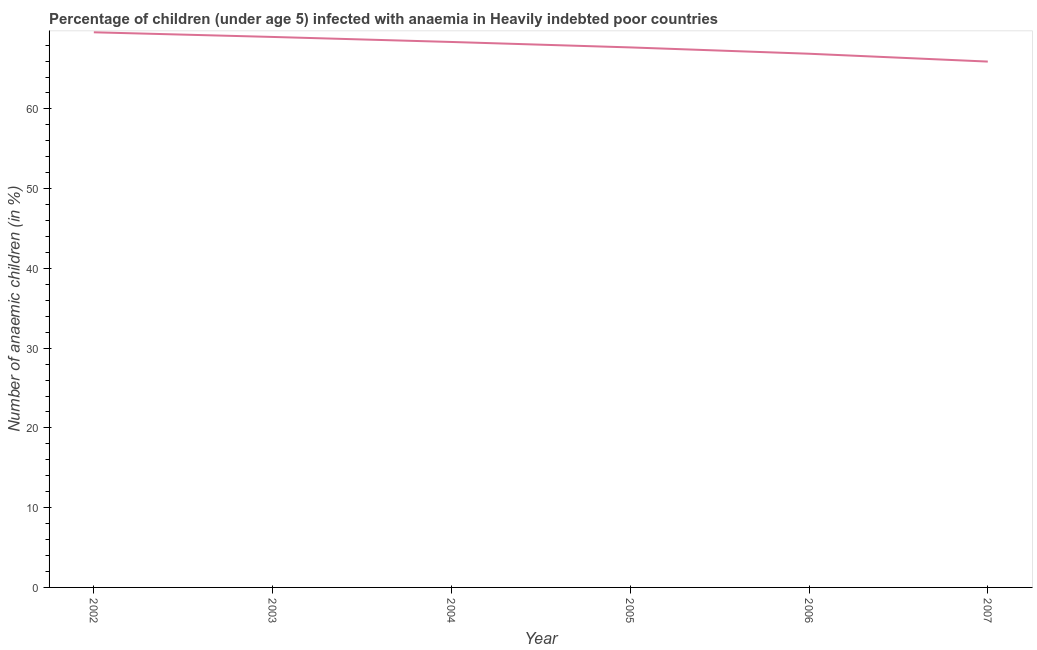What is the number of anaemic children in 2006?
Keep it short and to the point. 66.92. Across all years, what is the maximum number of anaemic children?
Keep it short and to the point. 69.61. Across all years, what is the minimum number of anaemic children?
Make the answer very short. 65.93. What is the sum of the number of anaemic children?
Offer a terse response. 407.59. What is the difference between the number of anaemic children in 2003 and 2004?
Offer a very short reply. 0.63. What is the average number of anaemic children per year?
Give a very brief answer. 67.93. What is the median number of anaemic children?
Provide a short and direct response. 68.05. Do a majority of the years between 2006 and 2004 (inclusive) have number of anaemic children greater than 44 %?
Your answer should be very brief. No. What is the ratio of the number of anaemic children in 2003 to that in 2005?
Provide a short and direct response. 1.02. What is the difference between the highest and the second highest number of anaemic children?
Offer a very short reply. 0.58. Is the sum of the number of anaemic children in 2003 and 2006 greater than the maximum number of anaemic children across all years?
Keep it short and to the point. Yes. What is the difference between the highest and the lowest number of anaemic children?
Your response must be concise. 3.67. Does the number of anaemic children monotonically increase over the years?
Keep it short and to the point. No. Are the values on the major ticks of Y-axis written in scientific E-notation?
Offer a very short reply. No. What is the title of the graph?
Provide a short and direct response. Percentage of children (under age 5) infected with anaemia in Heavily indebted poor countries. What is the label or title of the X-axis?
Give a very brief answer. Year. What is the label or title of the Y-axis?
Keep it short and to the point. Number of anaemic children (in %). What is the Number of anaemic children (in %) in 2002?
Keep it short and to the point. 69.61. What is the Number of anaemic children (in %) in 2003?
Offer a very short reply. 69.02. What is the Number of anaemic children (in %) of 2004?
Your answer should be compact. 68.39. What is the Number of anaemic children (in %) of 2005?
Ensure brevity in your answer.  67.71. What is the Number of anaemic children (in %) in 2006?
Ensure brevity in your answer.  66.92. What is the Number of anaemic children (in %) of 2007?
Keep it short and to the point. 65.93. What is the difference between the Number of anaemic children (in %) in 2002 and 2003?
Provide a short and direct response. 0.58. What is the difference between the Number of anaemic children (in %) in 2002 and 2004?
Keep it short and to the point. 1.21. What is the difference between the Number of anaemic children (in %) in 2002 and 2005?
Provide a succinct answer. 1.9. What is the difference between the Number of anaemic children (in %) in 2002 and 2006?
Your response must be concise. 2.69. What is the difference between the Number of anaemic children (in %) in 2002 and 2007?
Provide a short and direct response. 3.67. What is the difference between the Number of anaemic children (in %) in 2003 and 2004?
Offer a very short reply. 0.63. What is the difference between the Number of anaemic children (in %) in 2003 and 2005?
Offer a terse response. 1.31. What is the difference between the Number of anaemic children (in %) in 2003 and 2006?
Ensure brevity in your answer.  2.11. What is the difference between the Number of anaemic children (in %) in 2003 and 2007?
Your answer should be very brief. 3.09. What is the difference between the Number of anaemic children (in %) in 2004 and 2005?
Make the answer very short. 0.68. What is the difference between the Number of anaemic children (in %) in 2004 and 2006?
Your response must be concise. 1.48. What is the difference between the Number of anaemic children (in %) in 2004 and 2007?
Make the answer very short. 2.46. What is the difference between the Number of anaemic children (in %) in 2005 and 2006?
Provide a short and direct response. 0.79. What is the difference between the Number of anaemic children (in %) in 2005 and 2007?
Give a very brief answer. 1.78. What is the difference between the Number of anaemic children (in %) in 2006 and 2007?
Provide a short and direct response. 0.98. What is the ratio of the Number of anaemic children (in %) in 2002 to that in 2003?
Provide a short and direct response. 1.01. What is the ratio of the Number of anaemic children (in %) in 2002 to that in 2004?
Your response must be concise. 1.02. What is the ratio of the Number of anaemic children (in %) in 2002 to that in 2005?
Offer a terse response. 1.03. What is the ratio of the Number of anaemic children (in %) in 2002 to that in 2006?
Your answer should be very brief. 1.04. What is the ratio of the Number of anaemic children (in %) in 2002 to that in 2007?
Your answer should be compact. 1.06. What is the ratio of the Number of anaemic children (in %) in 2003 to that in 2004?
Offer a terse response. 1.01. What is the ratio of the Number of anaemic children (in %) in 2003 to that in 2006?
Ensure brevity in your answer.  1.03. What is the ratio of the Number of anaemic children (in %) in 2003 to that in 2007?
Ensure brevity in your answer.  1.05. What is the ratio of the Number of anaemic children (in %) in 2004 to that in 2006?
Ensure brevity in your answer.  1.02. What is the ratio of the Number of anaemic children (in %) in 2004 to that in 2007?
Keep it short and to the point. 1.04. What is the ratio of the Number of anaemic children (in %) in 2005 to that in 2006?
Your answer should be compact. 1.01. What is the ratio of the Number of anaemic children (in %) in 2005 to that in 2007?
Provide a succinct answer. 1.03. What is the ratio of the Number of anaemic children (in %) in 2006 to that in 2007?
Offer a terse response. 1.01. 